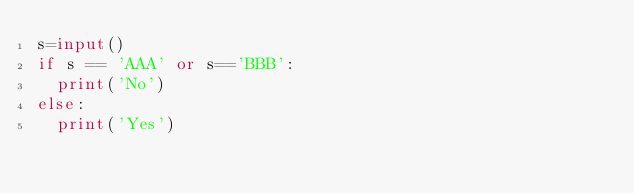<code> <loc_0><loc_0><loc_500><loc_500><_Python_>s=input()
if s == 'AAA' or s=='BBB':
  print('No')
else:
  print('Yes')</code> 